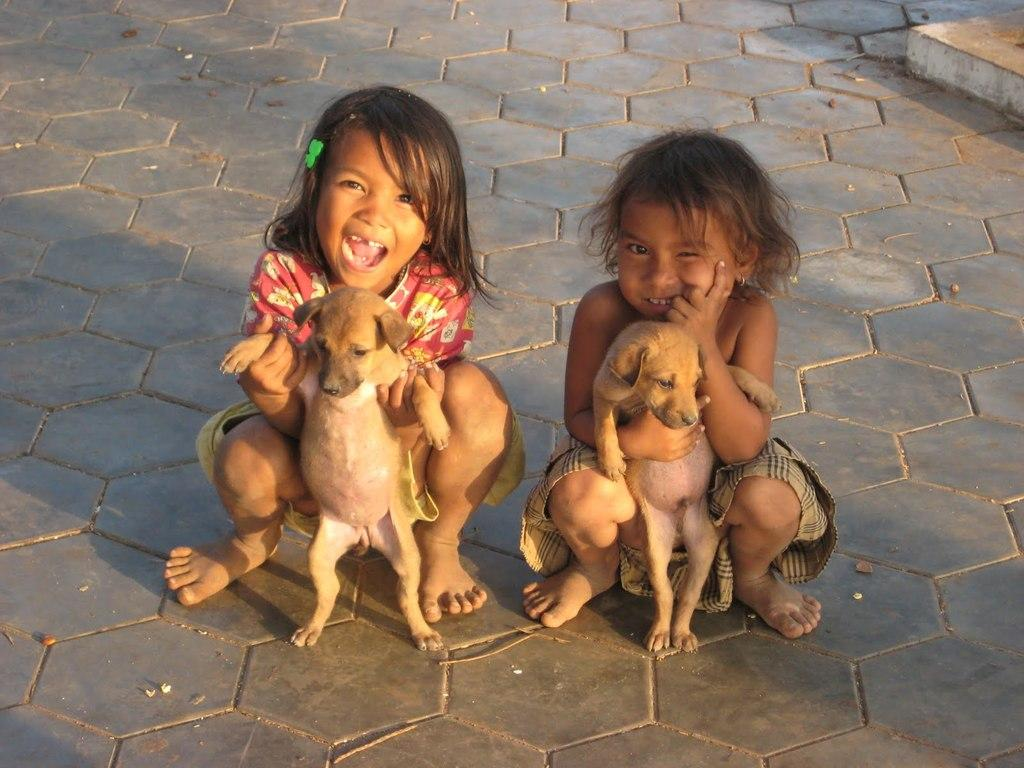How many kids are present in the image? There are two kids in the image. What are the kids holding in the image? Each kid is holding a dog. What type of lizards can be seen in the image? There are no lizards present in the image; it features two kids holding dogs. How much payment is being exchanged between the kids in the image? There is no payment being exchanged in the image; it simply shows two kids holding dogs. 